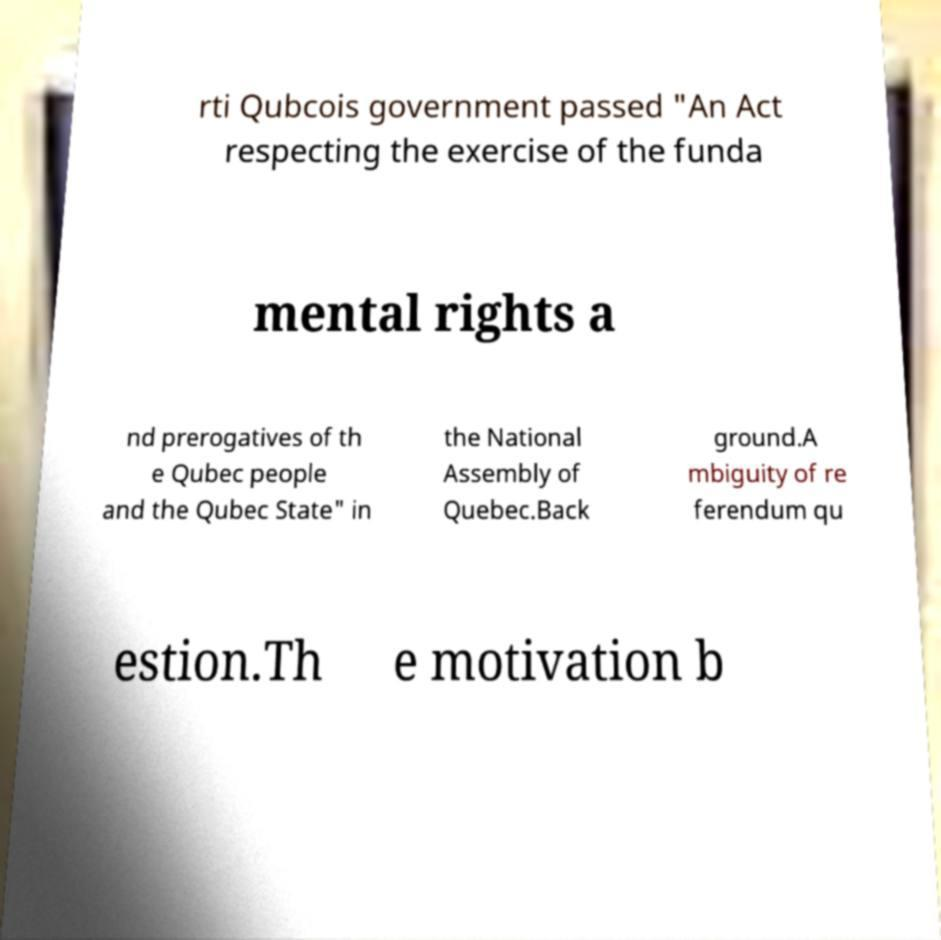What messages or text are displayed in this image? I need them in a readable, typed format. rti Qubcois government passed "An Act respecting the exercise of the funda mental rights a nd prerogatives of th e Qubec people and the Qubec State" in the National Assembly of Quebec.Back ground.A mbiguity of re ferendum qu estion.Th e motivation b 